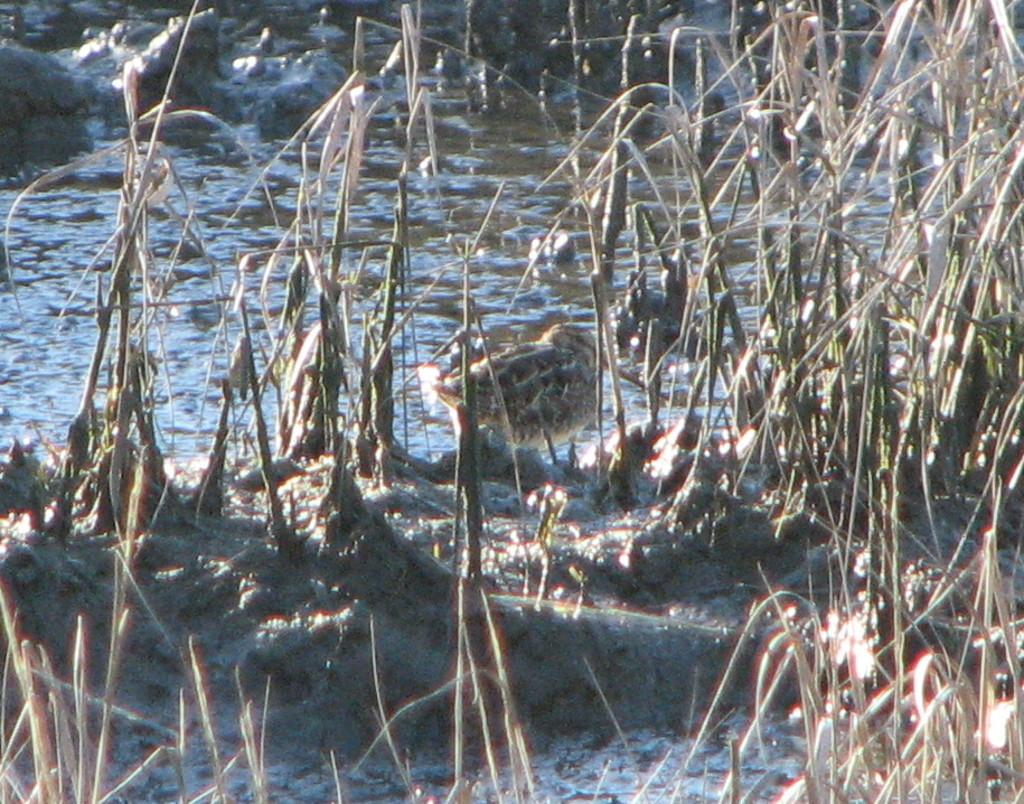What type of living organisms can be seen on the ground in the image? There are plants on the ground in the image. What other living organisms can be seen in the image? Birds are visible in the image. What is the primary element present in the image? There is water in the image. What can be seen in the background of the image? There are objects in the background of the image. How many dolls are floating in the water in the image? There are no dolls present in the image. What type of pollution can be seen in the image? There is no pollution visible in the image. 